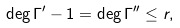Convert formula to latex. <formula><loc_0><loc_0><loc_500><loc_500>\deg \Gamma ^ { \prime } - 1 = \deg \Gamma ^ { \prime \prime } \leq r ,</formula> 